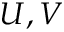<formula> <loc_0><loc_0><loc_500><loc_500>U , V</formula> 